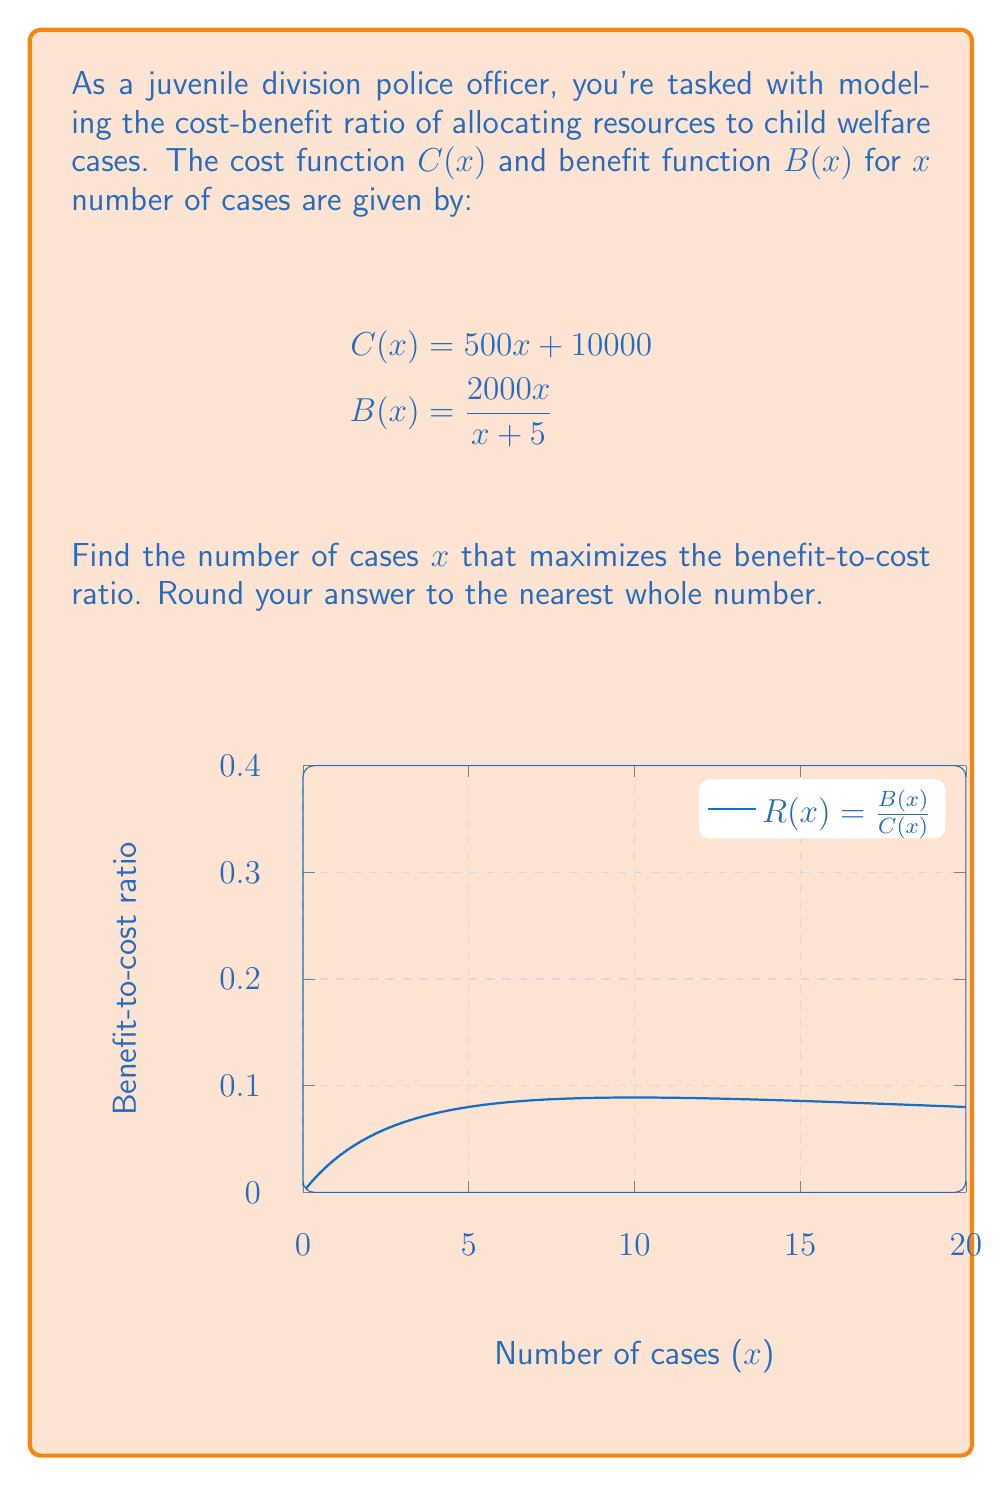What is the answer to this math problem? To find the maximum benefit-to-cost ratio, we need to:

1) Form the ratio function R(x) = B(x) / C(x)
2) Find the derivative R'(x)
3) Set R'(x) = 0 and solve for x
4) Verify it's a maximum

Step 1: Form the ratio function
$$R(x) = \frac{B(x)}{C(x)} = \frac{2000x / (x + 5)}{500x + 10000} = \frac{2000x}{(x + 5)(500x + 10000)}$$

Step 2: Find the derivative
Using the quotient rule:
$$R'(x) = \frac{(2000(x+5) - 2000x)(500x + 10000) - 2000x(500(x+5) + 0)}{((x+5)(500x + 10000))^2}$$
$$= \frac{10000(500x + 10000) - 2000x(500x + 12500)}{((x+5)(500x + 10000))^2}$$
$$= \frac{5000000x + 100000000 - 1000000x^2 - 25000000x}{((x+5)(500x + 10000))^2}$$
$$= \frac{-1000000x^2 - 20000000x + 100000000}{((x+5)(500x + 10000))^2}$$

Step 3: Set R'(x) = 0 and solve
$$-1000000x^2 - 20000000x + 100000000 = 0$$
$$-10x^2 - 200x + 1000 = 0$$
$$x^2 + 20x - 100 = 0$$
$$(x + 10)^2 = 200$$
$$x + 10 = \sqrt{200} \approx 14.14$$
$$x \approx 4.14$$

Step 4: Verify it's a maximum
We can confirm this is a maximum by checking the second derivative or by observing the graph.

Rounding to the nearest whole number, we get 4 cases.
Answer: 4 cases 